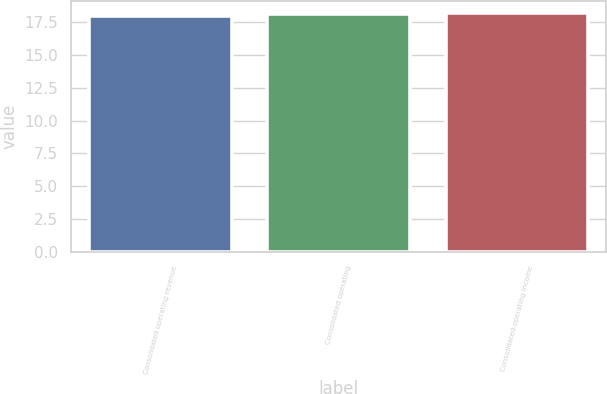Convert chart. <chart><loc_0><loc_0><loc_500><loc_500><bar_chart><fcel>Consolidated operating revenue<fcel>Consolidated operating<fcel>Consolidated operating income<nl><fcel>18<fcel>18.1<fcel>18.2<nl></chart> 